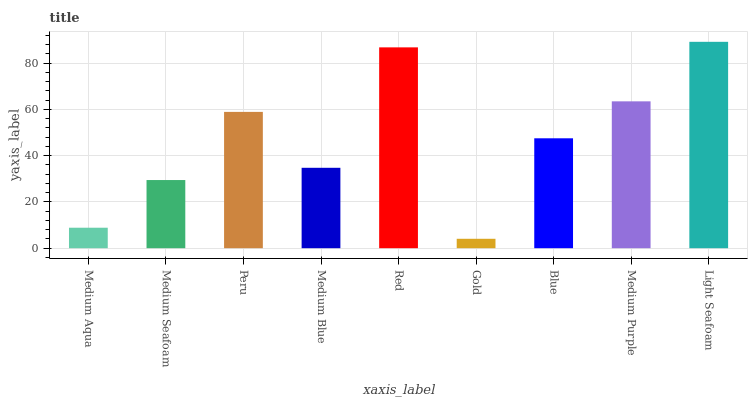Is Gold the minimum?
Answer yes or no. Yes. Is Light Seafoam the maximum?
Answer yes or no. Yes. Is Medium Seafoam the minimum?
Answer yes or no. No. Is Medium Seafoam the maximum?
Answer yes or no. No. Is Medium Seafoam greater than Medium Aqua?
Answer yes or no. Yes. Is Medium Aqua less than Medium Seafoam?
Answer yes or no. Yes. Is Medium Aqua greater than Medium Seafoam?
Answer yes or no. No. Is Medium Seafoam less than Medium Aqua?
Answer yes or no. No. Is Blue the high median?
Answer yes or no. Yes. Is Blue the low median?
Answer yes or no. Yes. Is Medium Purple the high median?
Answer yes or no. No. Is Medium Aqua the low median?
Answer yes or no. No. 